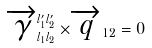<formula> <loc_0><loc_0><loc_500><loc_500>\overrightarrow { \gamma } _ { l _ { 1 } l _ { 2 } } ^ { l _ { 1 } ^ { \prime } l _ { 2 } ^ { \prime } } \times \overrightarrow { q } _ { 1 2 } = 0</formula> 